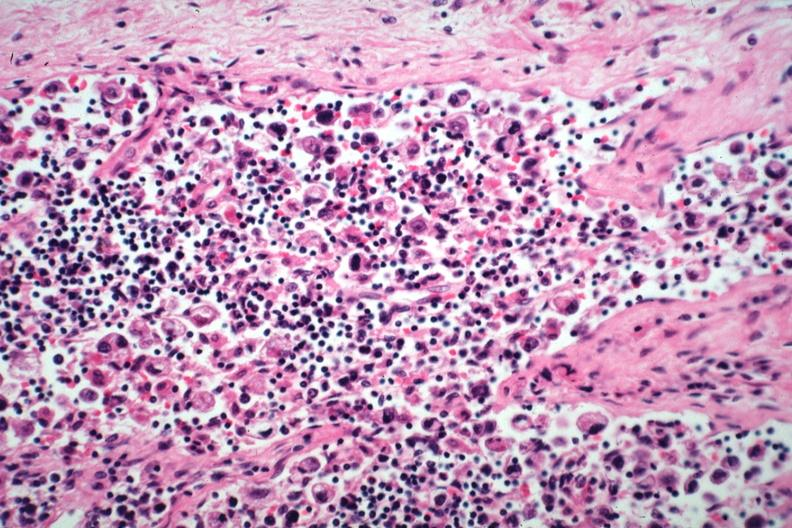s lymph node present?
Answer the question using a single word or phrase. Yes 